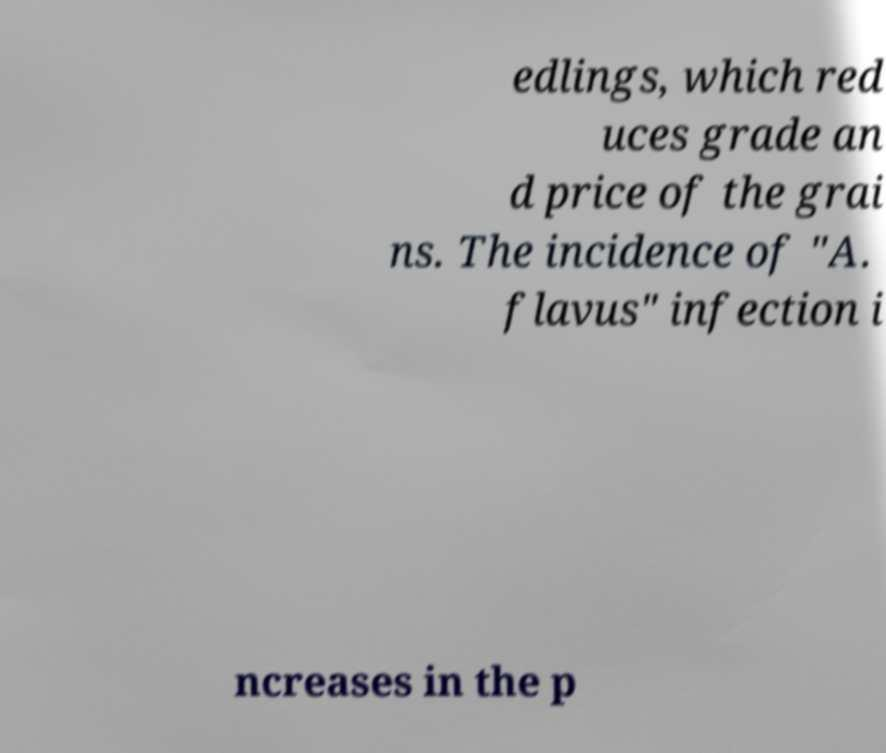There's text embedded in this image that I need extracted. Can you transcribe it verbatim? edlings, which red uces grade an d price of the grai ns. The incidence of "A. flavus" infection i ncreases in the p 